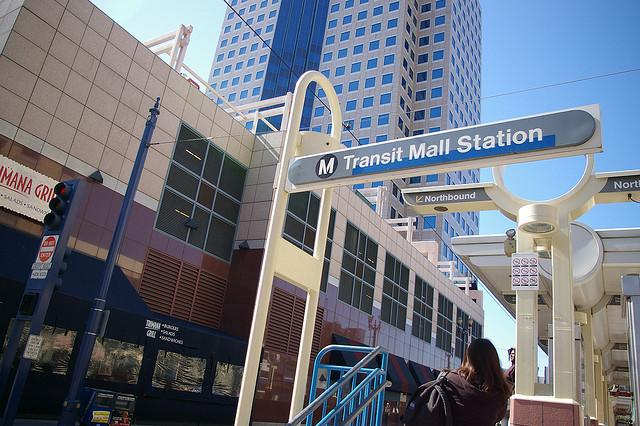What color is the light all the way to the left? Please explain your reasoning. red. The light on the left is red colored. 